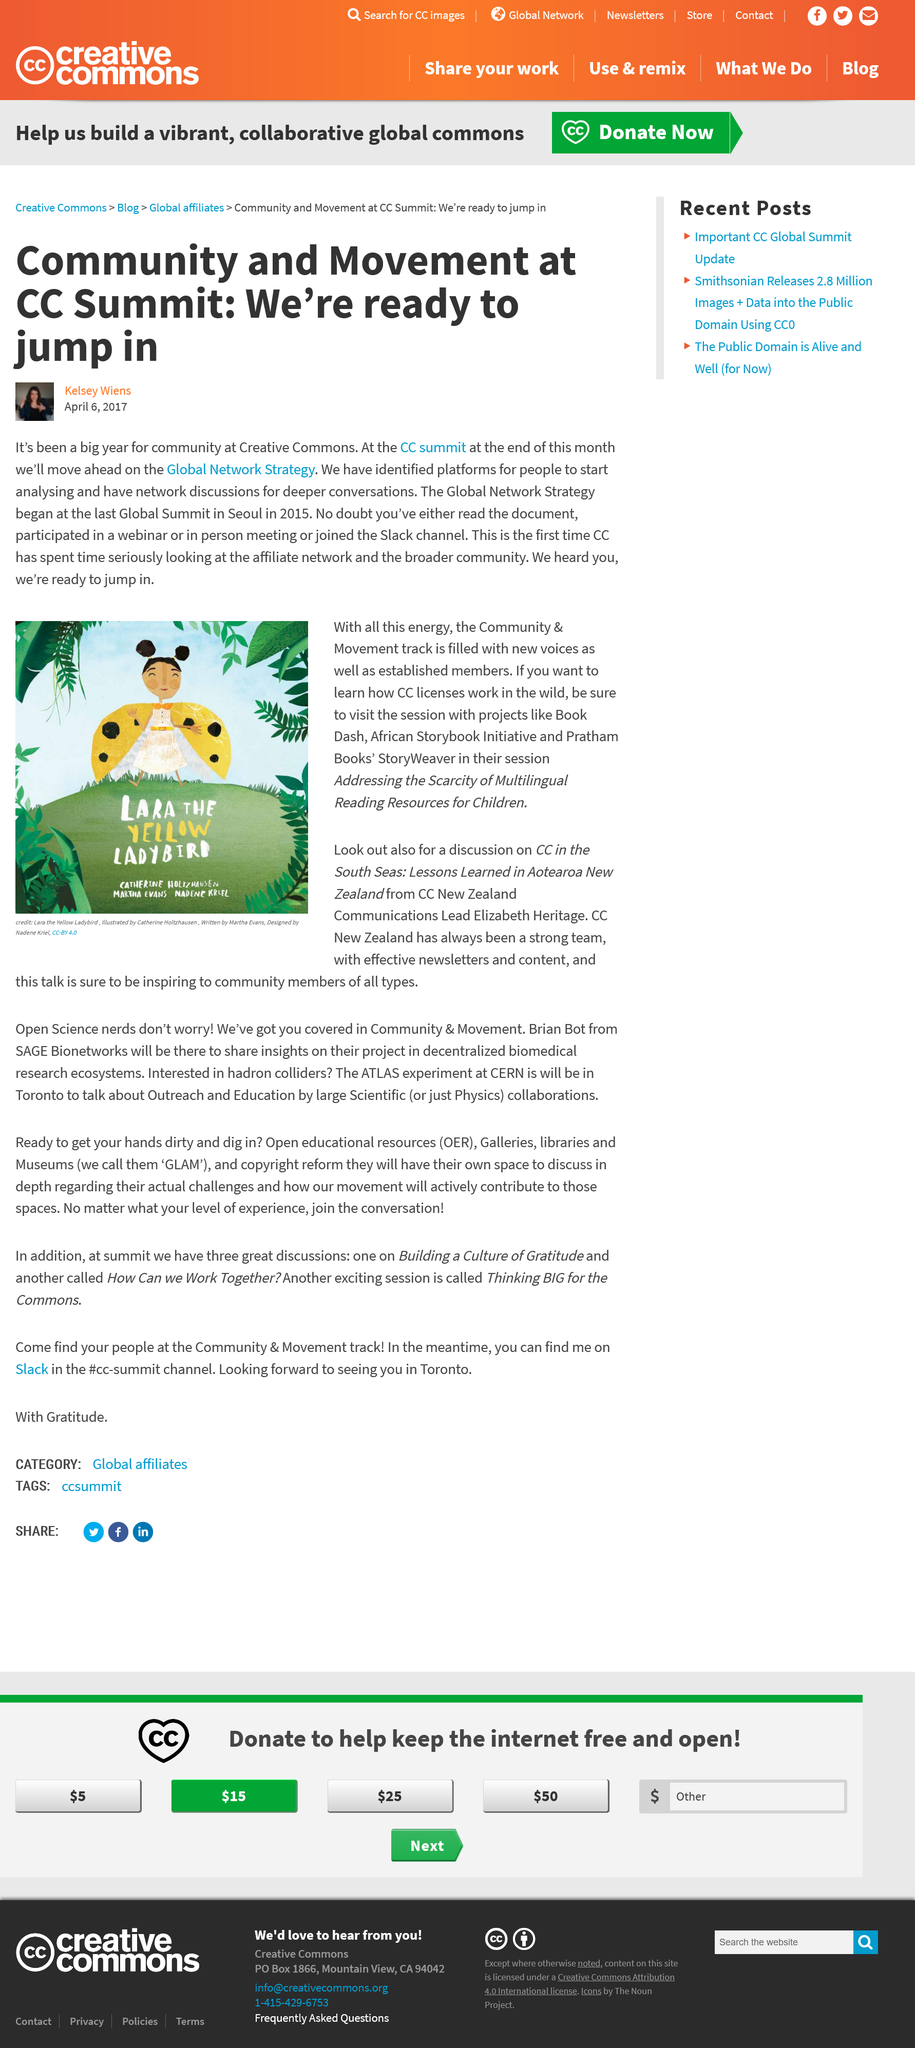Draw attention to some important aspects in this diagram. The name of the Slack channel associated with the CC Summit and Global Network Strategy is [the CC Summit and Global Network Strategy Slack Channel]. The last Global CC Summit took place in Seoul. Catherine Holtzhausen is the illustrator of Lara the Yellow Ladybird. Lara is a person who is described as being yellow in color. Lara the Yellow Ladybird is from New Zealand. 